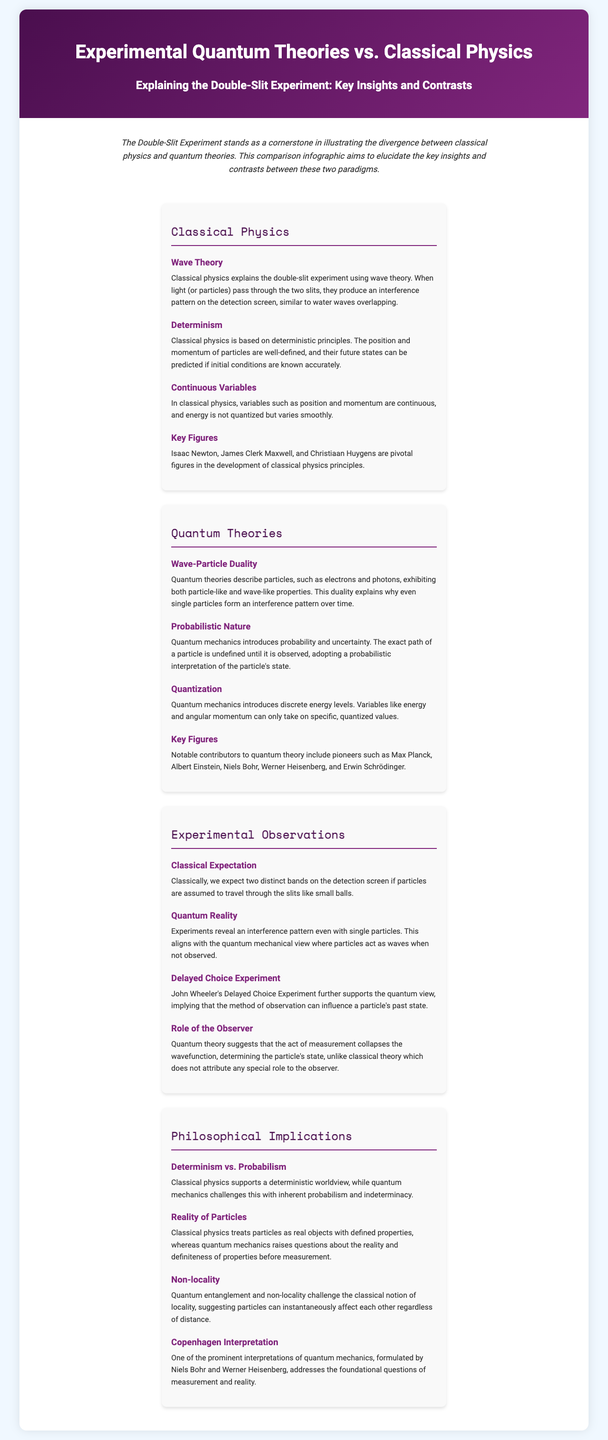What principle does classical physics primarily follow? The document states that classical physics is based on deterministic principles.
Answer: Deterministic Who is a key figure associated with quantum theories? The document lists notable contributors to quantum theory, which includes Max Planck and others.
Answer: Max Planck What experiment supports the quantum view by revealing the influence of observation? The document mentions the Delayed Choice Experiment that supports the quantum perspective.
Answer: Delayed Choice Experiment How does classical physics interpret variables like position and momentum? According to the document, classical physics views position and momentum as continuous variables.
Answer: Continuous What concept does quantum mechanics introduce that contrasts with classical determinism? The document highlights that quantum mechanics introduces a probabilistic nature.
Answer: Probabilistic nature Which interpretation of quantum mechanics addresses foundational questions of measurement? The document refers to the Copenhagen Interpretation as one that deals with measurement and reality.
Answer: Copenhagen Interpretation What is expected on the detection screen according to classical physics? The document states that classically, two distinct bands are expected on the detection screen.
Answer: Two distinct bands What does quantum theory suggest about the role of the observer? The document indicates that quantum theory suggests the act of measurement collapses the wavefunction.
Answer: Collapse of the wavefunction Who are foundational figures in classical physics mentioned in the document? The document lists Isaac Newton, James Clerk Maxwell, and Christiaan Huygens as pivotal figures.
Answer: Isaac Newton, James Clerk Maxwell, Christiaan Huygens 